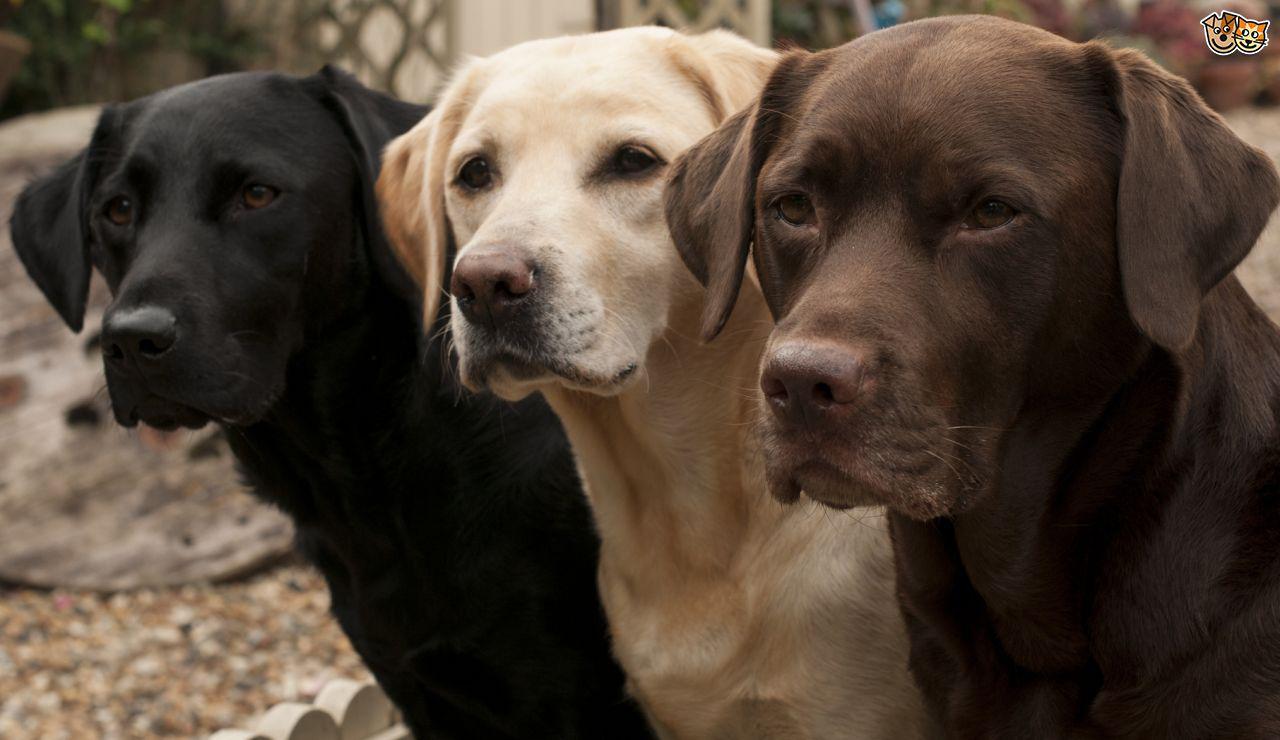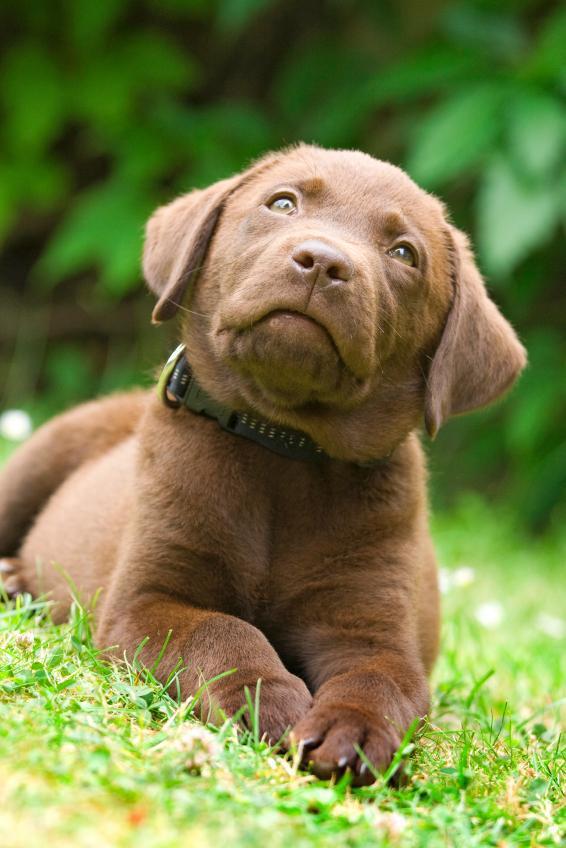The first image is the image on the left, the second image is the image on the right. For the images shown, is this caption "Four dogs exactly can be seen on the pair of images." true? Answer yes or no. Yes. The first image is the image on the left, the second image is the image on the right. Examine the images to the left and right. Is the description "An image contains exactly two dogs sitting upright, with the darker dog on the right." accurate? Answer yes or no. No. 